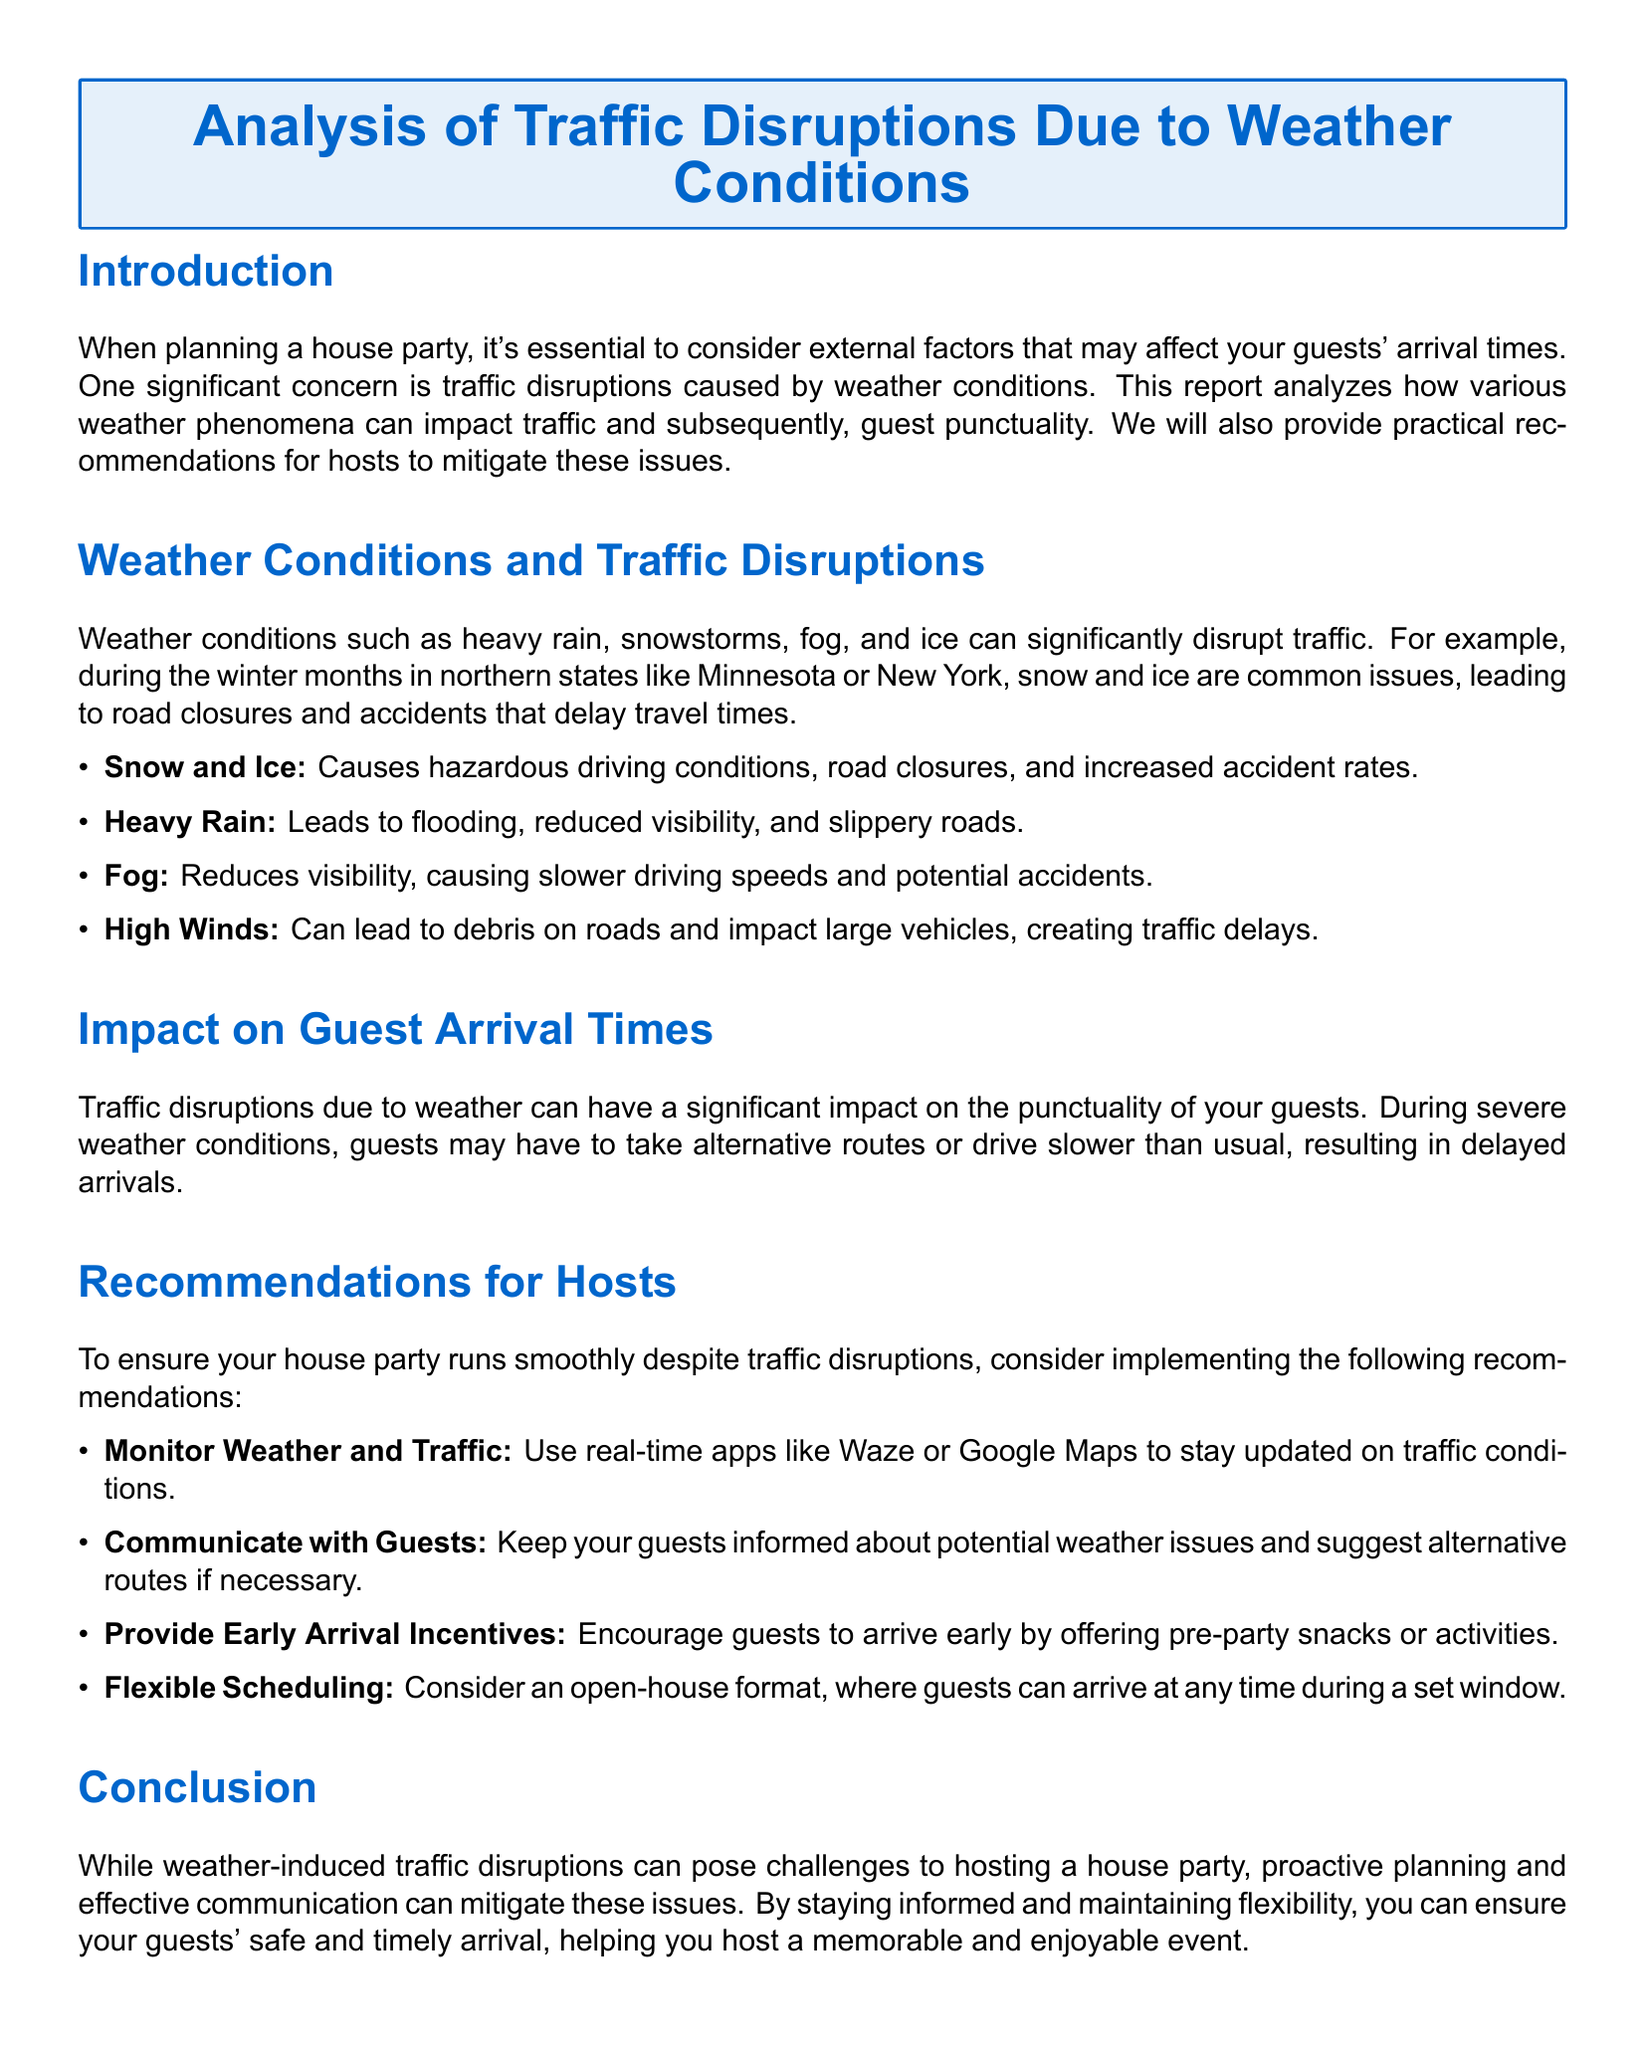What are three weather conditions mentioned that disrupt traffic? The document lists heavy rain, snowstorms, fog, and ice as weather conditions that affect traffic.
Answer: heavy rain, snowstorms, fog What is one major effect of snow and ice on traffic? The document states that snow and ice cause hazardous driving conditions, road closures, and increased accident rates.
Answer: hazardous driving conditions Which app is recommended for monitoring real-time traffic? The report suggests using real-time apps like Waze or Google Maps to stay updated on traffic conditions.
Answer: Waze or Google Maps What is one incentive hosts can provide to encourage early arrival? The document suggests offering pre-party snacks or activities as incentives for guests to arrive early.
Answer: pre-party snacks How can a flexible scheduling strategy help hosts? The document recommends an open-house format to allow guests to arrive at any time, which can help accommodate delays.
Answer: open-house format What is the main concern regarding guest arrival times? The document indicates that severe weather conditions can lead to delayed arrivals due to traffic disruptions.
Answer: delayed arrivals What is a key recommendation for communicating with guests? The report emphasizes the importance of keeping guests informed about potential weather issues and suggesting alternative routes.
Answer: communicate about potential weather issues What type of document is this? The title and content indicate that the document is an analysis report focused on traffic disruptions due to weather conditions.
Answer: Traffic report 